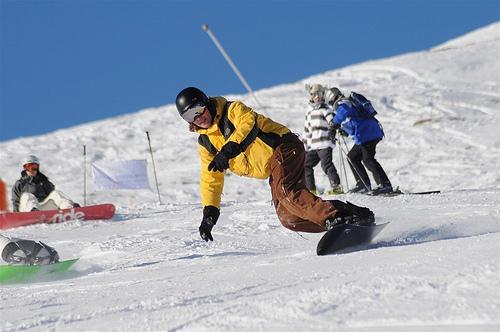What are they doing?
Write a very short answer. Snowboarding. How many snowboards are there?
Write a very short answer. 3. What is on the bottom of the red snowboard?
Short answer required. Ride. Is the man in yellow wearing the appropriate safety gear?
Quick response, please. Yes. 